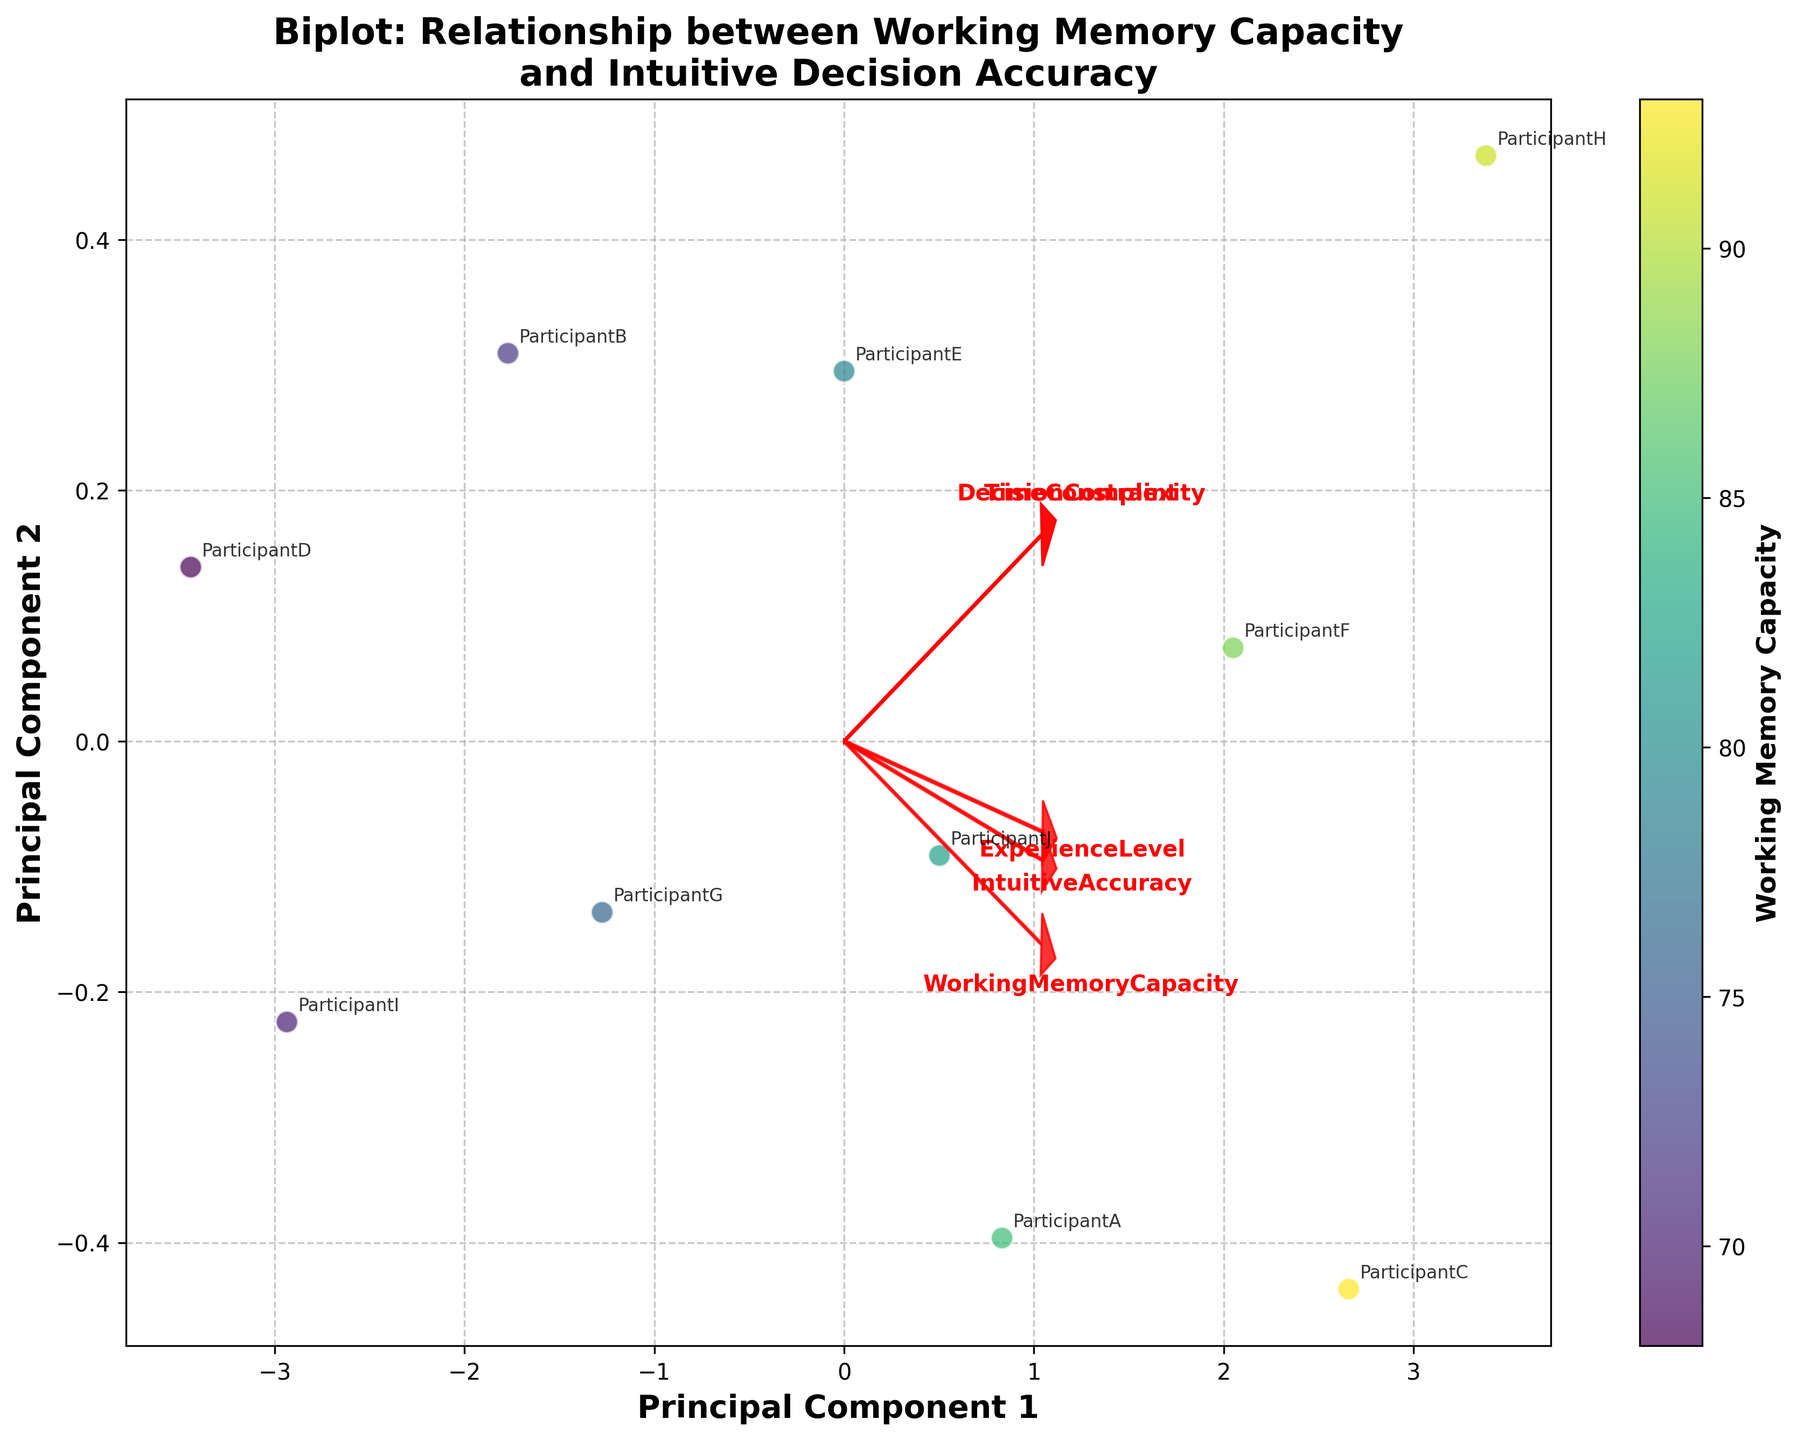How many principal components are shown in the biplot? The biplot shows two principal components as indicated by the labels on the X and Y axes ('Principal Component 1' and 'Principal Component 2').
Answer: Two What color represents higher levels of Working Memory Capacity in the biplot? The biplot uses a color gradient that moves from yellow to green. Higher levels of Working Memory Capacity are represented by the green color at the higher end of the color bar.
Answer: Green Which variable has the largest loading on Principal Component 1? To find this, observe the arrows in the plot that are labeled with variable names. The length and direction of the arrows indicate the loading. The variable with the furthest arrow in the direction of Principal Component 1 has the largest loading on PC1.
Answer: IntuitiveAccuracy Are there any participants with similar Principal Component scores? Participants that are close to each other in the scatter plot have similar principal component scores. Checking the annotations will show if there are clustered participants.
Answer: Yes Which participant has the highest score on Principal Component 2? Look at the Y-axis values and find the participant annotation that is highest on this axis.
Answer: Participant H How does Time Constraint relate to Principal Component 2? The arrow for Time Constraint should be analyzed in relation to its direction and length on the Principal Component 2 axis. If aiming upward, it has a positive relationship; downward indicates a negative relationship.
Answer: Positive Relationship Is the Decision Complexity variable more aligned with Principal Component 1 or 2? Observe the orientation of the Decision Complexity arrow. If it aligns more closely with the X-axis (PC1) or Y-axis (PC2), this tells us which component it is more aligned with.
Answer: Principal Component 1 How are Working Memory Capacity and Intuitive Accuracy related as per the biplot? Analyze the direction and closeness of the arrows for both variables. If they point in similar directions and are close, they are positively correlated.
Answer: Positively Correlated Which variable appears to have the least influence on Principal Component 2? Examine the lengths and directions of the arrows. The variable with the shortest projection on the Y-axis (PC2) contributes the least.
Answer: Experience Level Is there a clear visual separation of participants based on Working Memory Capacity in the biplot? Look at the distribution and clustering of points relative to the color gradient representing Working Memory Capacity. Separate clusters for different colors indicate clear separation.
Answer: No 